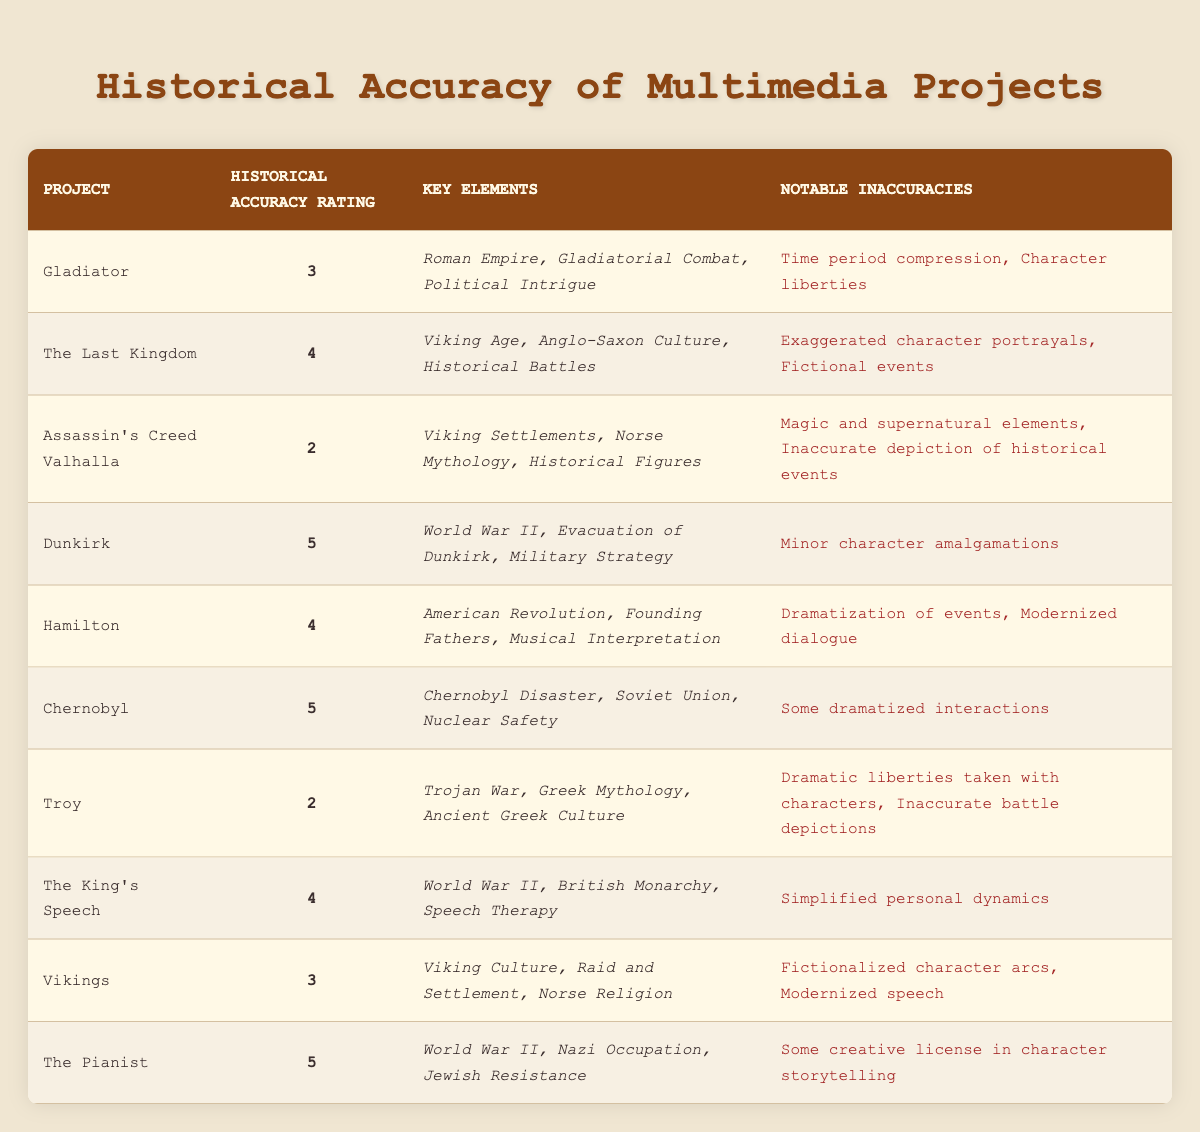What is the historical accuracy rating of "Dunkirk"? The historical accuracy rating for "Dunkirk" is clearly stated in the corresponding row of the table. Simply locate the project "Dunkirk" and read across to find the rating under the "Historical Accuracy Rating" column, which is 5.
Answer: 5 Which project has the lowest historical accuracy rating? To identify the project with the lowest historical accuracy rating, scan the "Historical Accuracy Rating" column and find the smallest value. The lowest rating of 2 belongs to "Assassin's Creed Valhalla" and "Troy".
Answer: Assassin's Creed Valhalla and Troy What notable inaccuracies are listed for "Hamilton"? To find the notable inaccuracies listed for "Hamilton", locate the row corresponding to the project and refer to the "Notable Inaccuracies" column. The inaccuracies mentioned include "Dramatization of events" and "Modernized dialogue".
Answer: Dramatization of events, Modernized dialogue How many projects have a historical accuracy rating of 4 or higher? First, identify which projects have a rating of 4 or higher by reviewing the "Historical Accuracy Rating" column. The projects that meet this criterion are "The Last Kingdom", "Hamilton", "The King's Speech", "Dunkirk", and "Chernobyl". Counting them gives a total of 5 projects.
Answer: 5 Is "Vikings" rated higher than "Gladiator"? To determine this, compare the historical accuracy ratings in the "Historical Accuracy Rating" column. "Vikings" has a rating of 3, while "Gladiator" also has a rating of 3. Since they are equal, the answer is no.
Answer: No What is the average historical accuracy rating of the projects listed in the table? To calculate the average rating, sum up all the historical accuracy ratings: 3 + 4 + 2 + 5 + 4 + 5 + 2 + 4 + 3 + 5 = 43. Then, divide this sum by the number of projects, which is 10. Thus, the average is 43 / 10 = 4.3.
Answer: 4.3 What key elements are mentioned for "Chernobyl"? Locate the project "Chernobyl" in the table and check the "Key Elements" column for the details. The key elements listed are "Chernobyl Disaster", "Soviet Union", and "Nuclear Safety".
Answer: Chernobyl Disaster, Soviet Union, Nuclear Safety Did "The Pianist" have any notable inaccuracies? Check the row for "The Pianist" to see if any notable inaccuracies are reported in the respective column. The table indicates that "The Pianist" did have notable inaccuracies, specifically "Some creative license in character storytelling".
Answer: Yes 